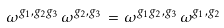Convert formula to latex. <formula><loc_0><loc_0><loc_500><loc_500>\omega ^ { g _ { 1 } , g _ { 2 } g _ { 3 } } \, \omega ^ { g _ { 2 } , g _ { 3 } } \, = \, \omega ^ { g _ { 1 } g _ { 2 } , g _ { 3 } } \, \omega ^ { g _ { 1 } , g _ { 2 } }</formula> 